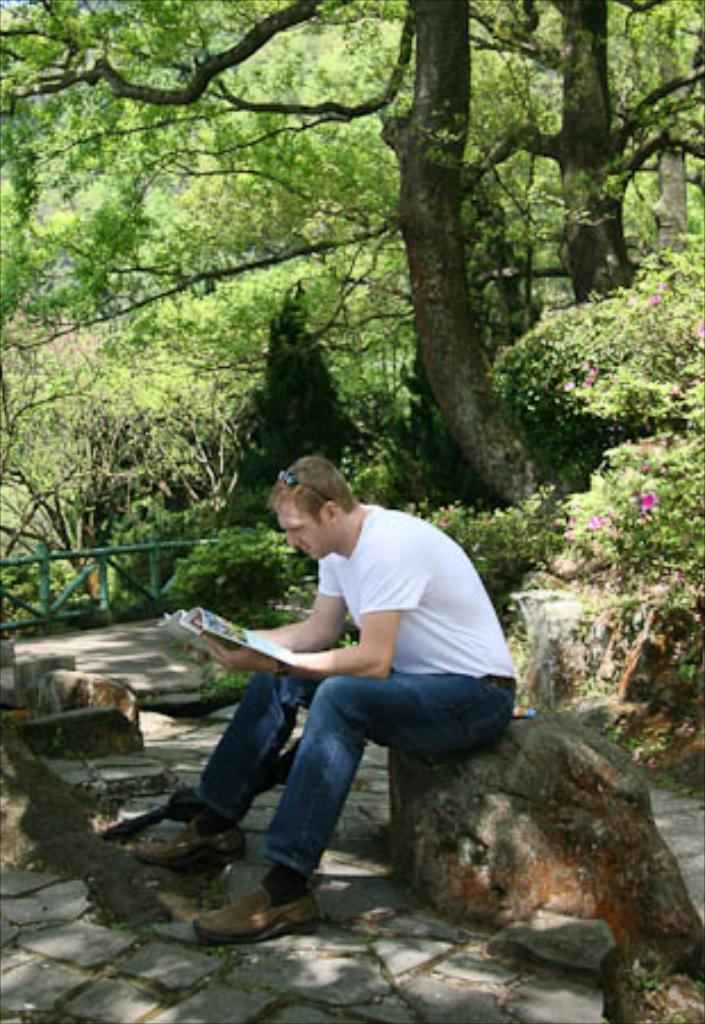Who is in the picture? There is a man in the picture. What is the man wearing? The man is wearing a white T-shirt and blue jeans. What is the man doing in the picture? The man is sitting on a rock. What can be seen in the background of the image? There are trees in the background of the image. What type of wristwatch is the man wearing in the image? There is no wristwatch visible in the image; the man is only wearing a white T-shirt and blue jeans. How many wrens can be seen perched on the rock in the image? There are no wrens present in the image; the man is sitting on the rock alone. 